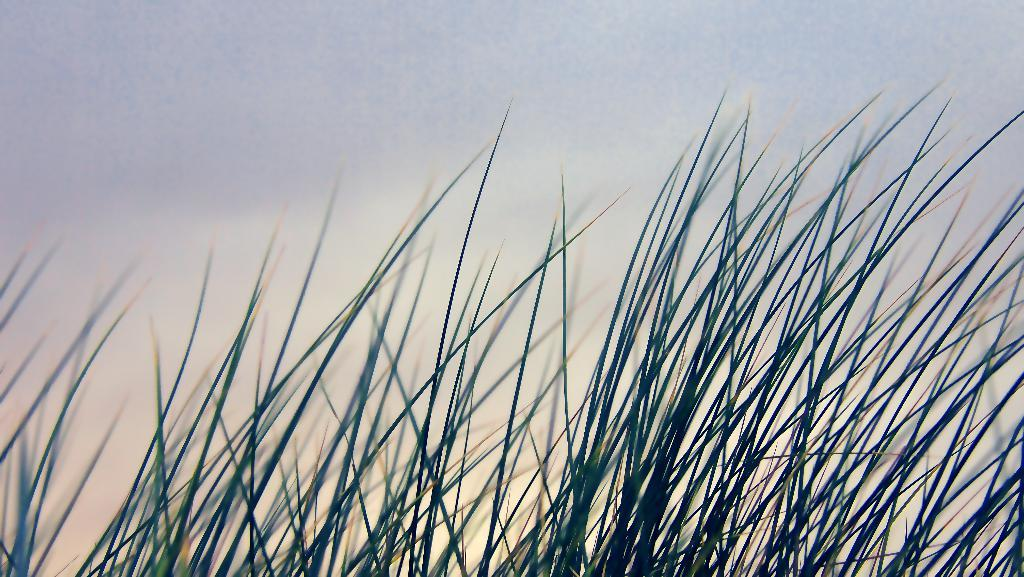What type of vegetation can be seen in the image? There is grass in the image. What part of the natural environment is visible in the image? The sky is visible in the image. Where is the sofa located in the image? There is no sofa present in the image. What color is the orange in the image? There is no orange present in the image. Can you see a giraffe in the image? There is no giraffe present in the image. 